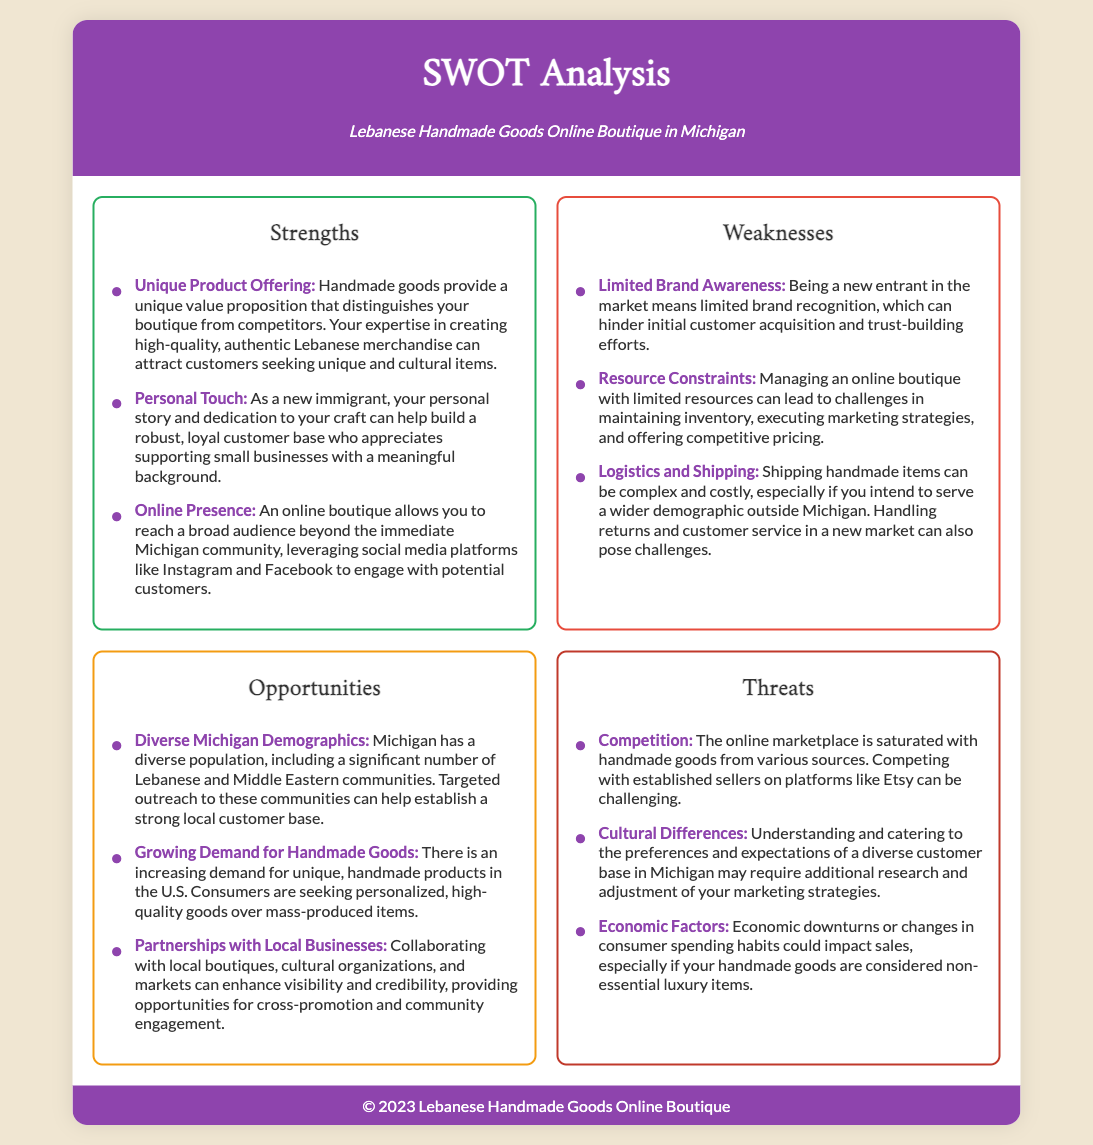what is the title of the document? The title is displayed prominently in the document header section, indicating the topic of the SWOT analysis.
Answer: SWOT Analysis what is one strength listed in the document? The document mentions specific strengths in a dedicated section, showcasing the unique advantages of the boutique.
Answer: Unique Product Offering what is one weakness mentioned? A list of weaknesses provides insight into challenges faced by the boutique, which can impact its growth.
Answer: Limited Brand Awareness how many opportunities are identified? The document lists several opportunities, which highlight potential avenues for growth and success.
Answer: Three what is one threat listed? The document outlines various threats that could affect the business, emphasizing potential hurdles in the market.
Answer: Competition which demographic is mentioned as a target market in the opportunities section? The opportunities section highlights specific demographics that the boutique could focus on for customer acquisition.
Answer: Lebanese and Middle Eastern communities what is the border color for the strengths section? The visual elements in the document use specific colors to differentiate the sections, including strengths.
Answer: Green what does the personal touch strength relate to? The document connects this strength to the business owner’s background and story, affecting customer relationships.
Answer: Dedication to craft how are partnerships with local businesses categorized? The SWOT analysis categorizes various strategies and relationships that can impact the boutique in its opportunities section.
Answer: Opportunities what is the background color of the document? The overall design of the document features a specific color scheme for aesthetic appeal and clarity.
Answer: Light beige 